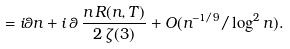Convert formula to latex. <formula><loc_0><loc_0><loc_500><loc_500>= i \theta n + i \, \theta \, \frac { n \, R ( n , T ) } { 2 \, \zeta ( 3 ) } + O ( n ^ { - 1 / 9 } / \log ^ { 2 } n ) .</formula> 